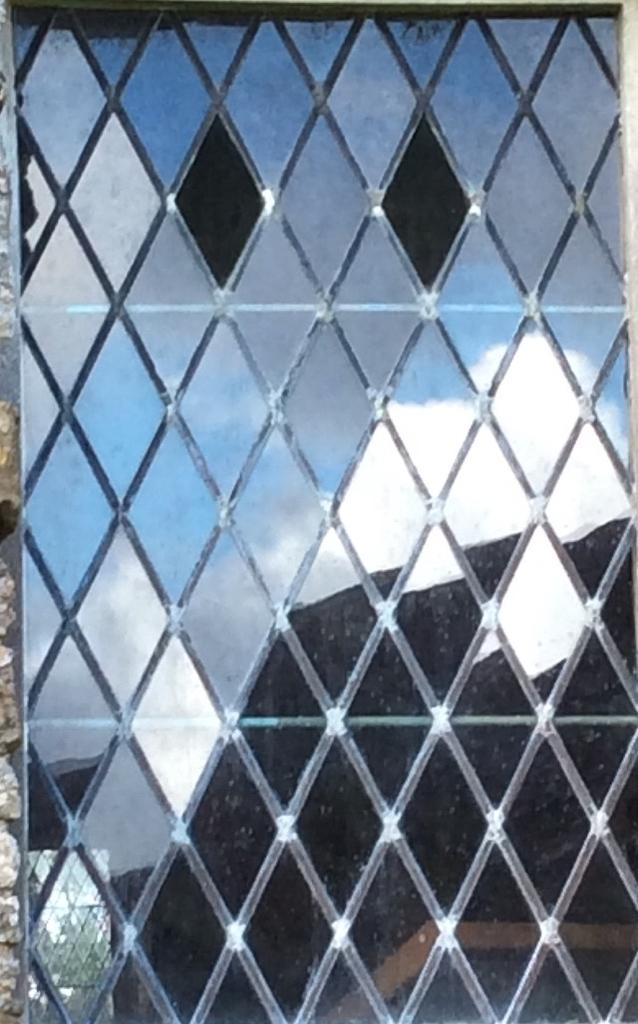What type of surface is present in the image that allows for reflections? There is a glass window in the image that allows for reflections. What can be seen in the reflections on the window? The reflection of a house, a tree, the sky, and clouds are visible on the window. What is located on the left side of the image? There is a wall on the left side of the image. What language is being spoken by the attraction in the image? There is no attraction present in the image, so it is not possible to determine what language might be spoken. 